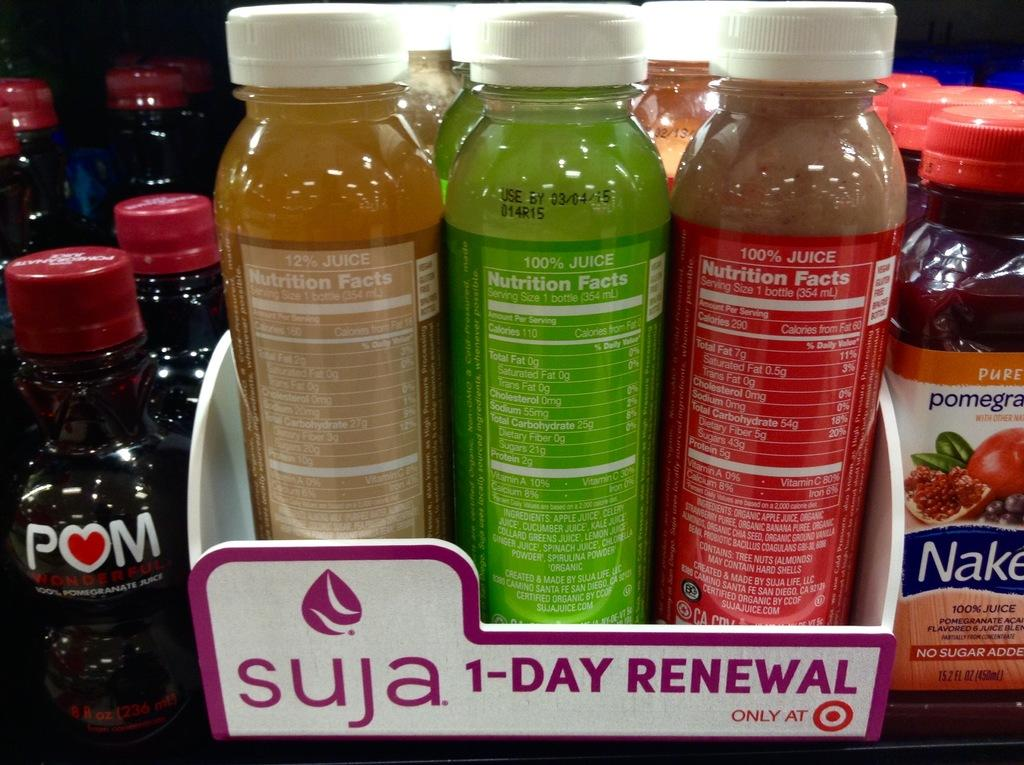<image>
Relay a brief, clear account of the picture shown. A collection of bottles in a box that says Suja on it. 